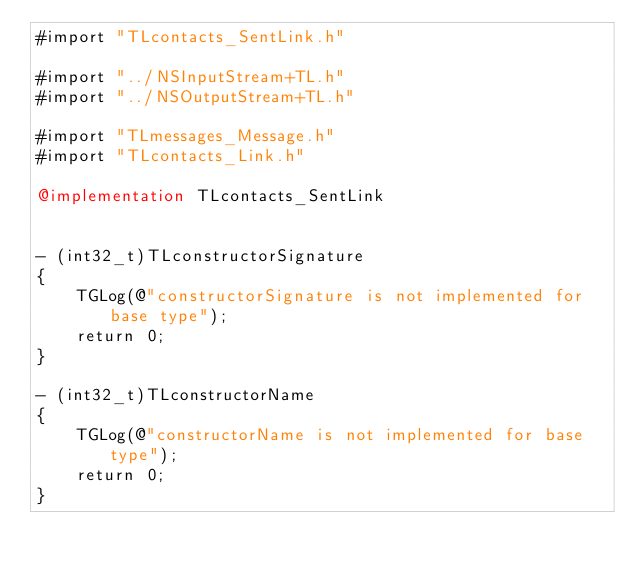Convert code to text. <code><loc_0><loc_0><loc_500><loc_500><_ObjectiveC_>#import "TLcontacts_SentLink.h"

#import "../NSInputStream+TL.h"
#import "../NSOutputStream+TL.h"

#import "TLmessages_Message.h"
#import "TLcontacts_Link.h"

@implementation TLcontacts_SentLink


- (int32_t)TLconstructorSignature
{
    TGLog(@"constructorSignature is not implemented for base type");
    return 0;
}

- (int32_t)TLconstructorName
{
    TGLog(@"constructorName is not implemented for base type");
    return 0;
}
</code> 